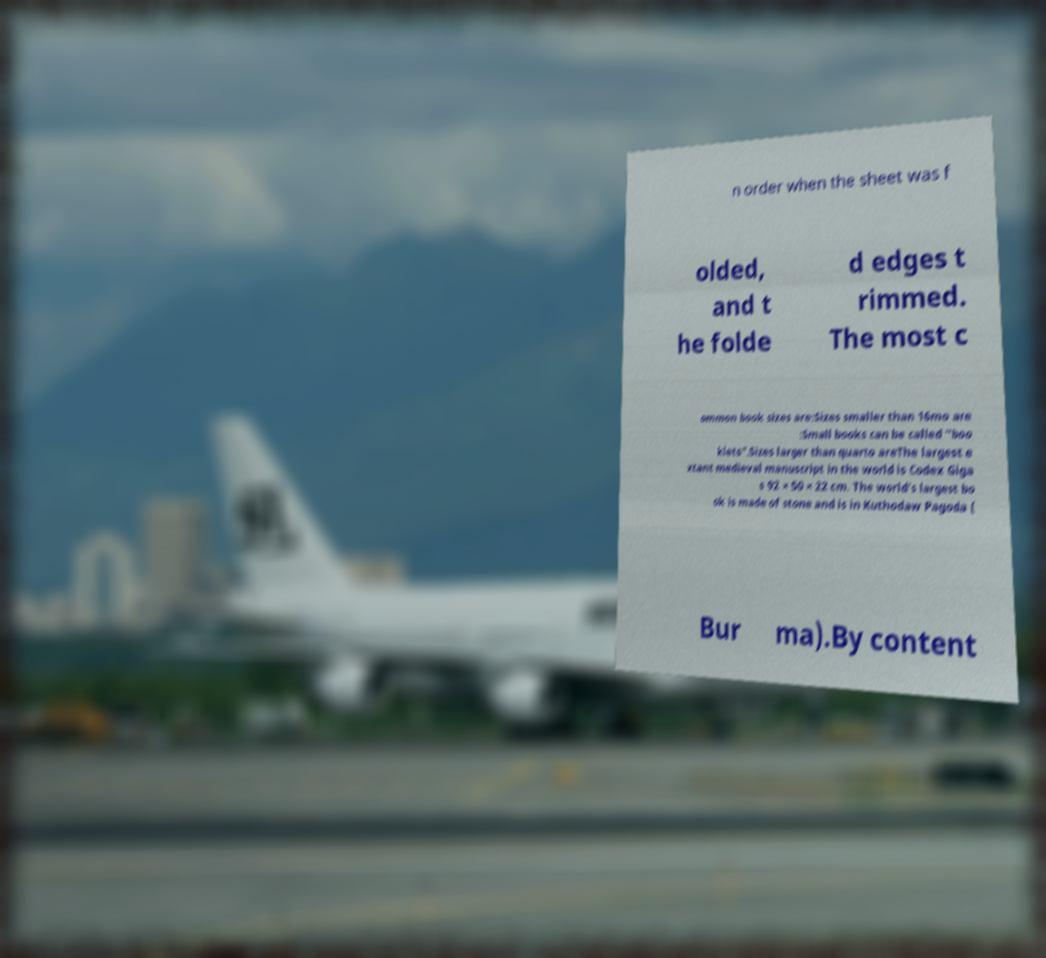Could you assist in decoding the text presented in this image and type it out clearly? n order when the sheet was f olded, and t he folde d edges t rimmed. The most c ommon book sizes are:Sizes smaller than 16mo are :Small books can be called "boo klets".Sizes larger than quarto areThe largest e xtant medieval manuscript in the world is Codex Giga s 92 × 50 × 22 cm. The world's largest bo ok is made of stone and is in Kuthodaw Pagoda ( Bur ma).By content 